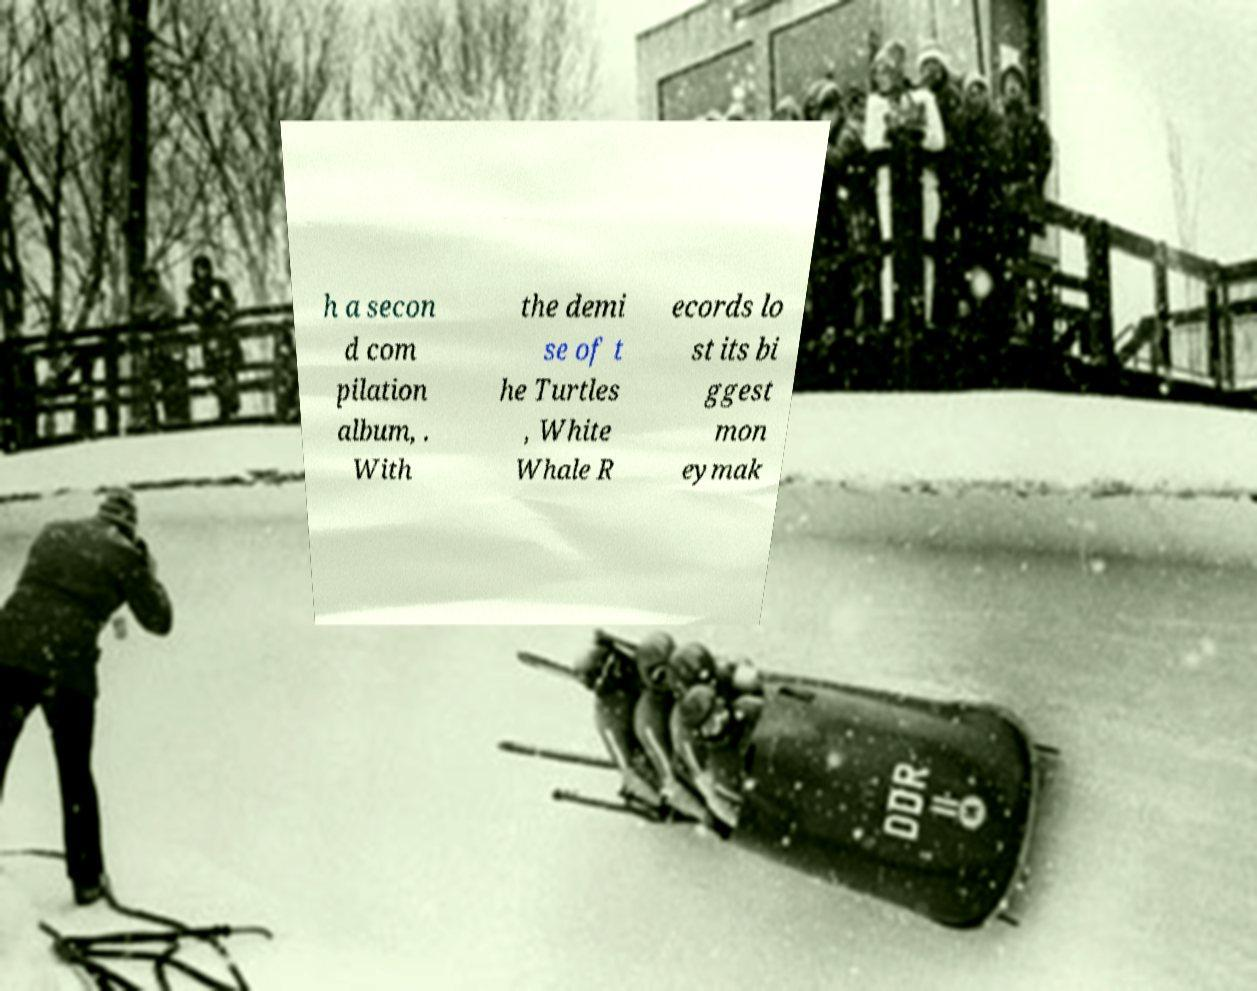Could you extract and type out the text from this image? h a secon d com pilation album, . With the demi se of t he Turtles , White Whale R ecords lo st its bi ggest mon eymak 